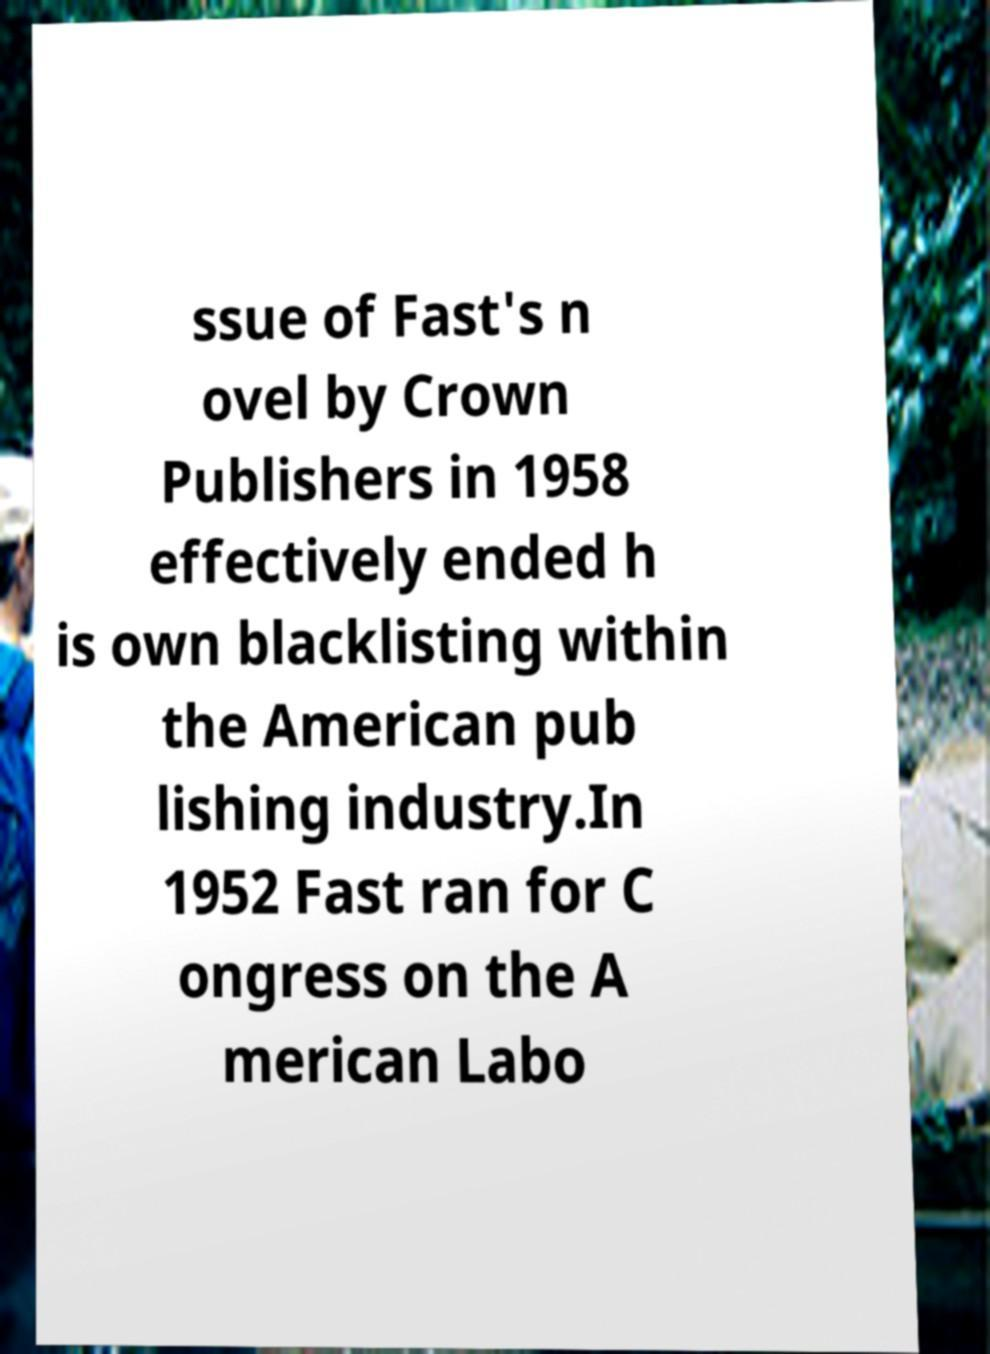Could you extract and type out the text from this image? ssue of Fast's n ovel by Crown Publishers in 1958 effectively ended h is own blacklisting within the American pub lishing industry.In 1952 Fast ran for C ongress on the A merican Labo 